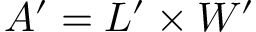<formula> <loc_0><loc_0><loc_500><loc_500>A ^ { \prime } = L ^ { \prime } \times W ^ { \prime }</formula> 